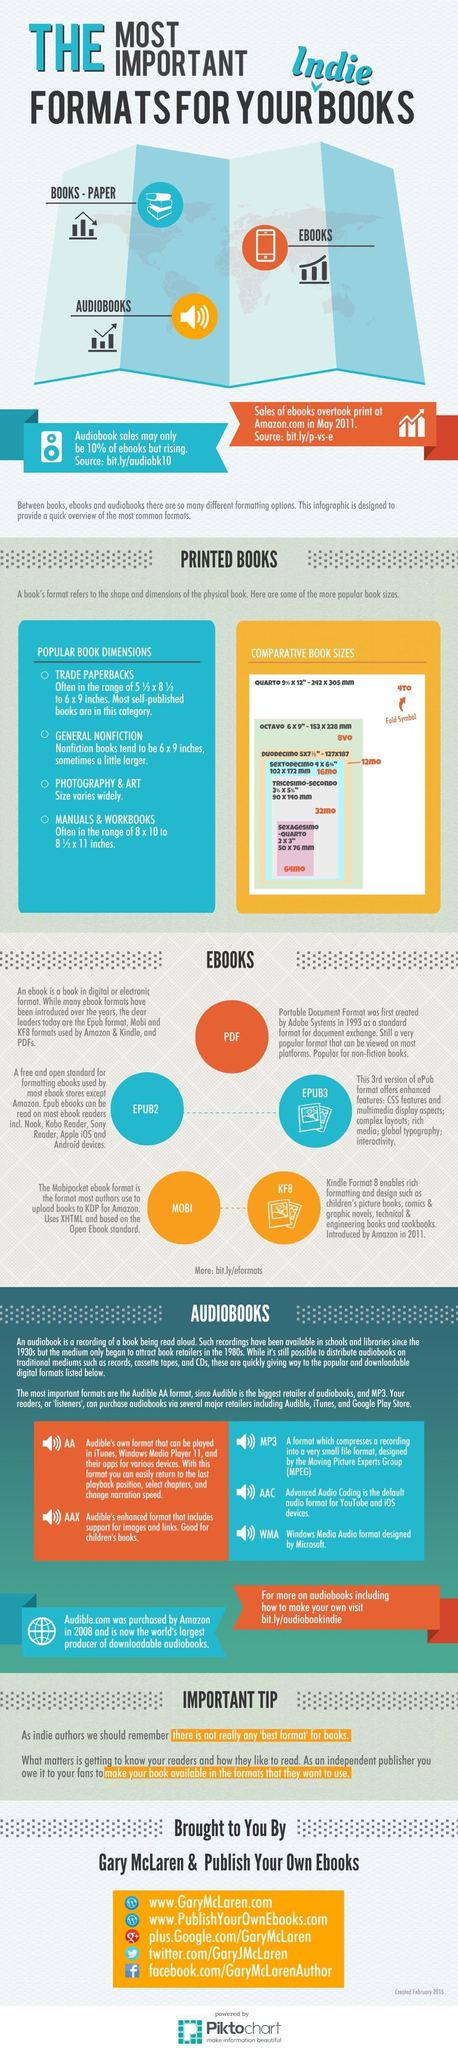Which audio book formats were not developed by Audible ?
Answer the question with a short phrase. MP3, AAC, WMA Which type books shows a decrease in sales in May 2011, Paper books, E- Books, or Audiobooks? Paper books How many types of EBook formats are there? 5 